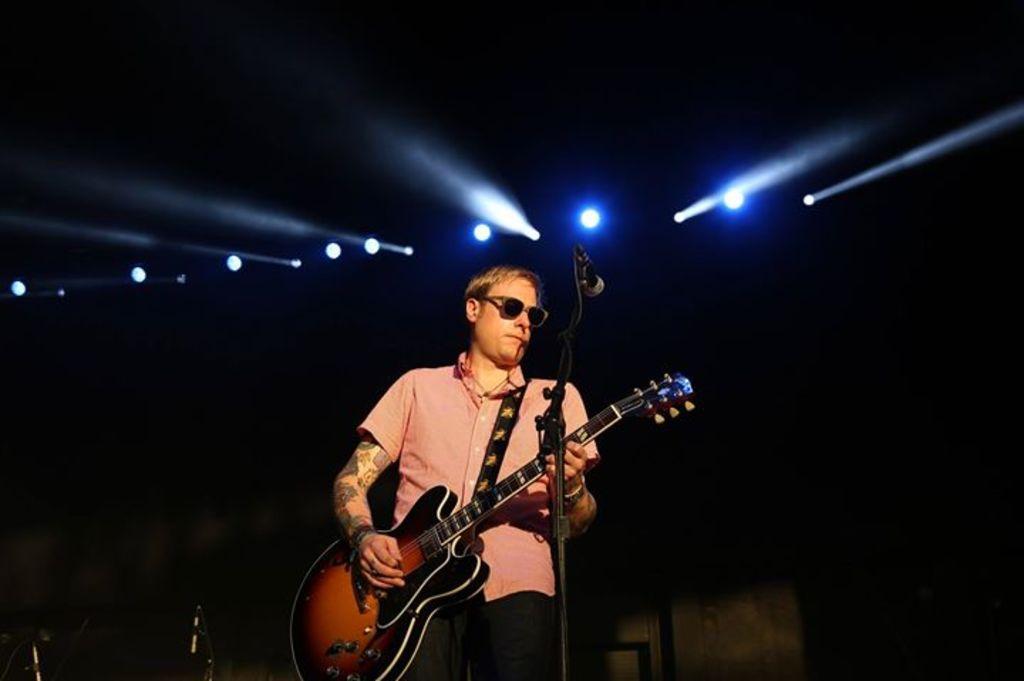Could you give a brief overview of what you see in this image? In the image we can see there is a man who is holding a guitar in his hand and in front of him there is a mike with a stand. 